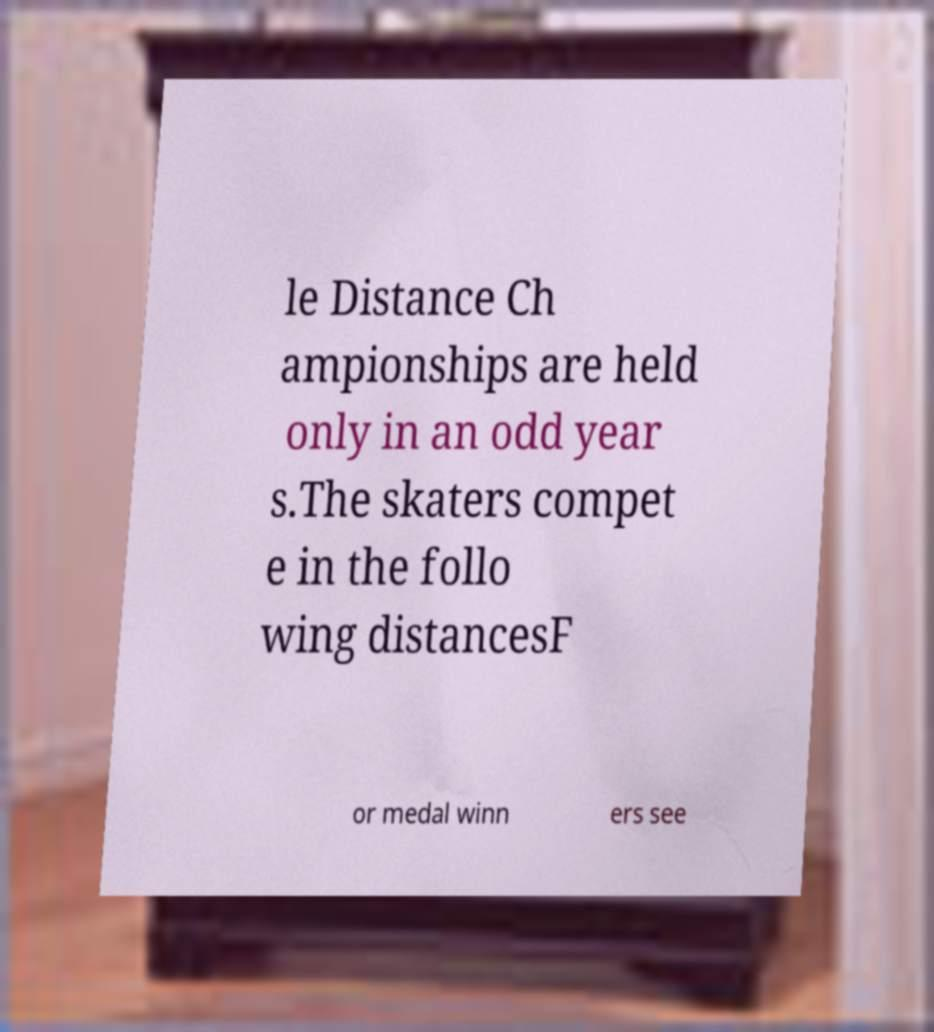Could you assist in decoding the text presented in this image and type it out clearly? le Distance Ch ampionships are held only in an odd year s.The skaters compet e in the follo wing distancesF or medal winn ers see 